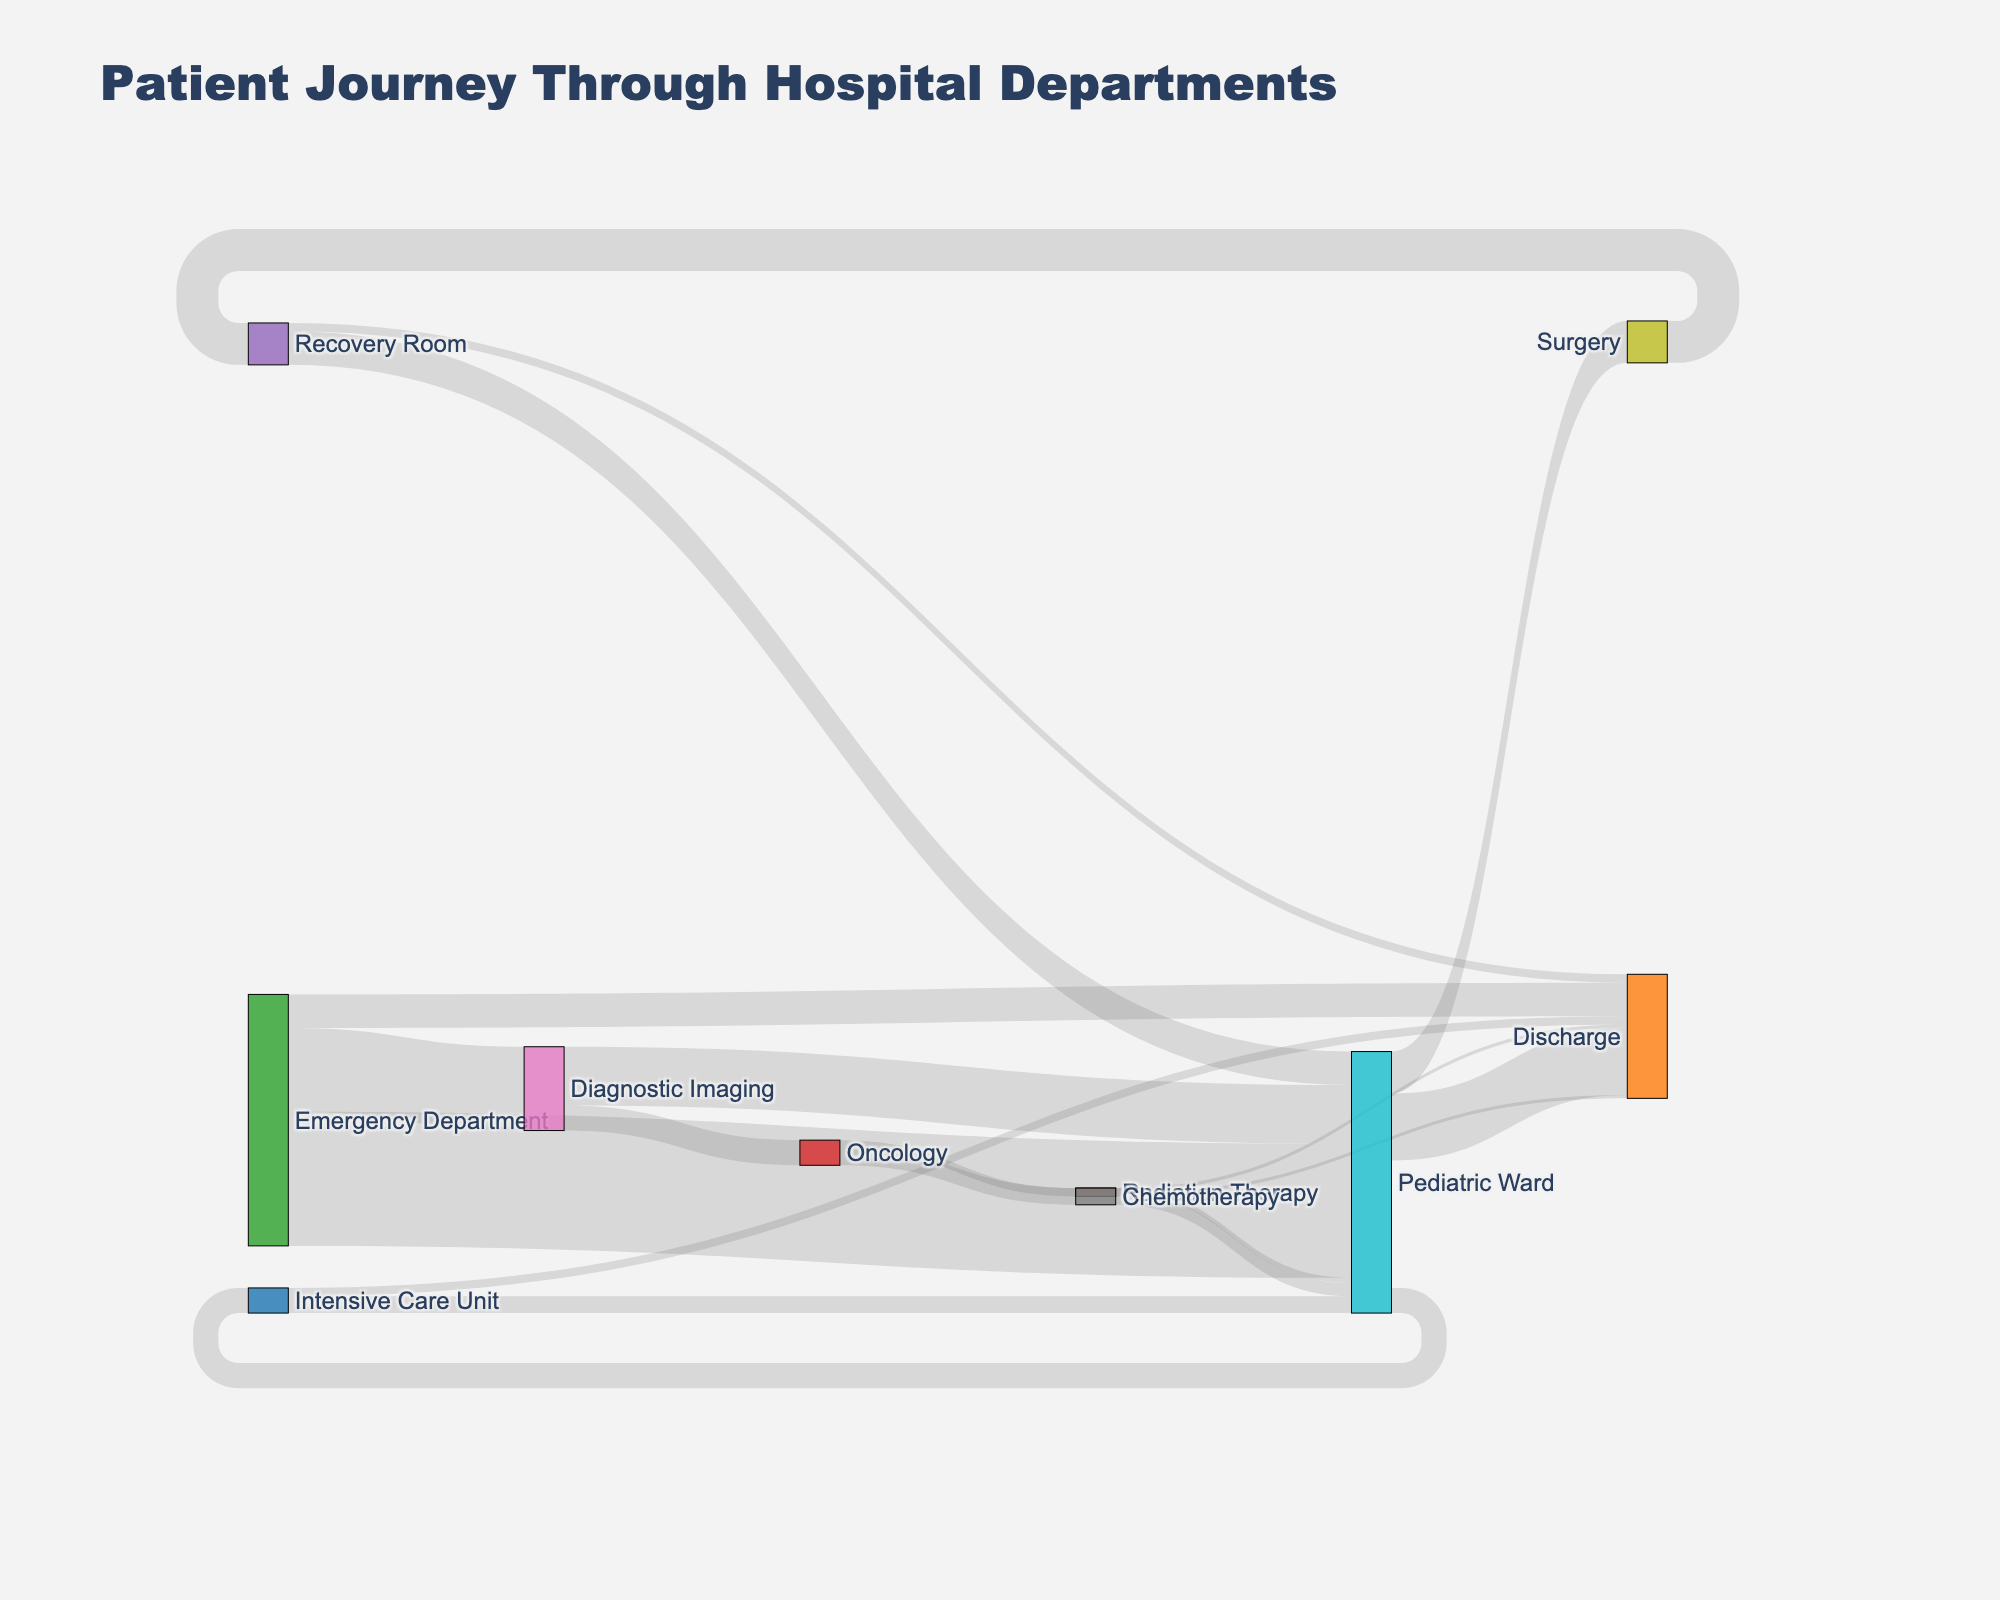What's the title of the diagram? The title is typically the largest text at the top of the figure. In this case, it's relevant to the context of the data presented, reflecting the content and what the diagram is representing.
Answer: Patient Journey Through Hospital Departments Which department do the most patients go to directly from the Emergency Department? Look at the width of the flows coming out of the Emergency Department node. The widest flow indicates the largest number of patients.
Answer: Pediatric Ward How many patients are discharged directly from the Emergency Department? Find the flow labeled "Discharge" originating from the Emergency Department and note the value.
Answer: 20 What is the total number of patients that are discharged from the hospital? Sum the values of all flows labeled "Discharge" from different departments.
Answer: 20 (Emergency Department) + 40 (Pediatric Ward) + 5 (Intensive Care Unit) + 5 (Recovery Room) + 2 (Chemotherapy) + 2 (Radiation Therapy) = 74 Which department sees the most patients after Pediatric Ward? Identify all the flows that come out of the Pediatric Ward and compare their lengths. The longest flow will indicate the department that receives the most patients from Pediatric Ward. The options are Intensive Care Unit, Surgery, and Discharge.
Answer: Discharge How many patients receive treatment in the Intensive Care Unit before getting discharged? Look for the flow originating from the Intensive Care Unit going to "Discharge".
Answer: 5 What is the sum of patients who moved from Diagnostic Imaging to other departments? Include all destination departments of patients from Diagnostic Imaging. Sum the values for Pediatric Ward and Oncology.
Answer: 35 (Pediatric Ward) + 15 (Oncology) = 50 From which department do patients most frequently return to the Pediatric Ward? Analyze all flows leading to the Pediatric Ward and identify their origins. Compare the number of patients for each flow.
Answer: Recovery Room How many patients move from Oncology to Chemotherapy and Radiation Therapy combined? Sum the values of patients moving from Oncology to Chemotherapy and Radiation Therapy.
Answer: 10 (Chemotherapy) + 5 (Radiation Therapy) = 15 